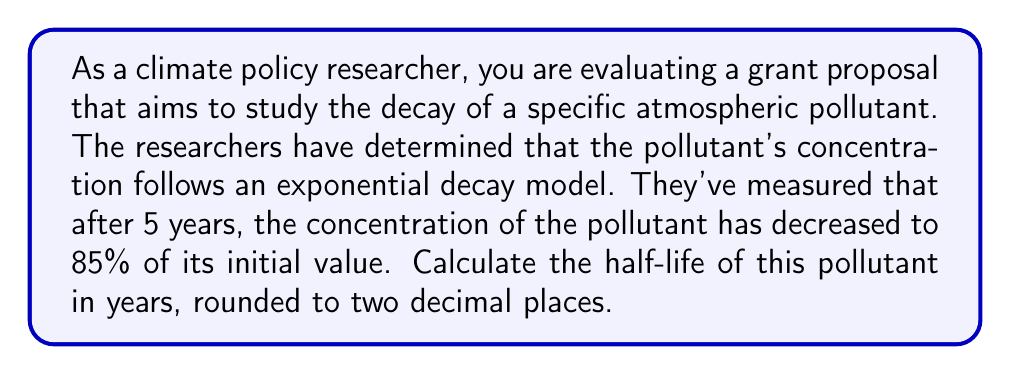Give your solution to this math problem. To solve this problem, we'll use the exponential decay formula and the definition of half-life:

1) The exponential decay formula is:

   $$ A(t) = A_0 \cdot e^{-\lambda t} $$

   Where $A(t)$ is the amount at time $t$, $A_0$ is the initial amount, $\lambda$ is the decay constant, and $t$ is time.

2) We're given that after 5 years, 85% of the initial amount remains. We can express this as:

   $$ 0.85 = e^{-5\lambda} $$

3) Taking the natural log of both sides:

   $$ \ln(0.85) = -5\lambda $$

4) Solve for $\lambda$:

   $$ \lambda = -\frac{\ln(0.85)}{5} \approx 0.0326 \text{ year}^{-1} $$

5) The half-life $t_{1/2}$ is defined as the time it takes for half of the substance to decay. We can express this using the decay formula:

   $$ 0.5 = e^{-\lambda t_{1/2}} $$

6) Taking the natural log of both sides:

   $$ \ln(0.5) = -\lambda t_{1/2} $$

7) Substitute our calculated $\lambda$ and solve for $t_{1/2}$:

   $$ t_{1/2} = -\frac{\ln(0.5)}{\lambda} = -\frac{\ln(0.5)}{0.0326} \approx 21.26 \text{ years} $$

8) Rounding to two decimal places gives us 21.26 years.
Answer: The half-life of the atmospheric pollutant is 21.26 years. 